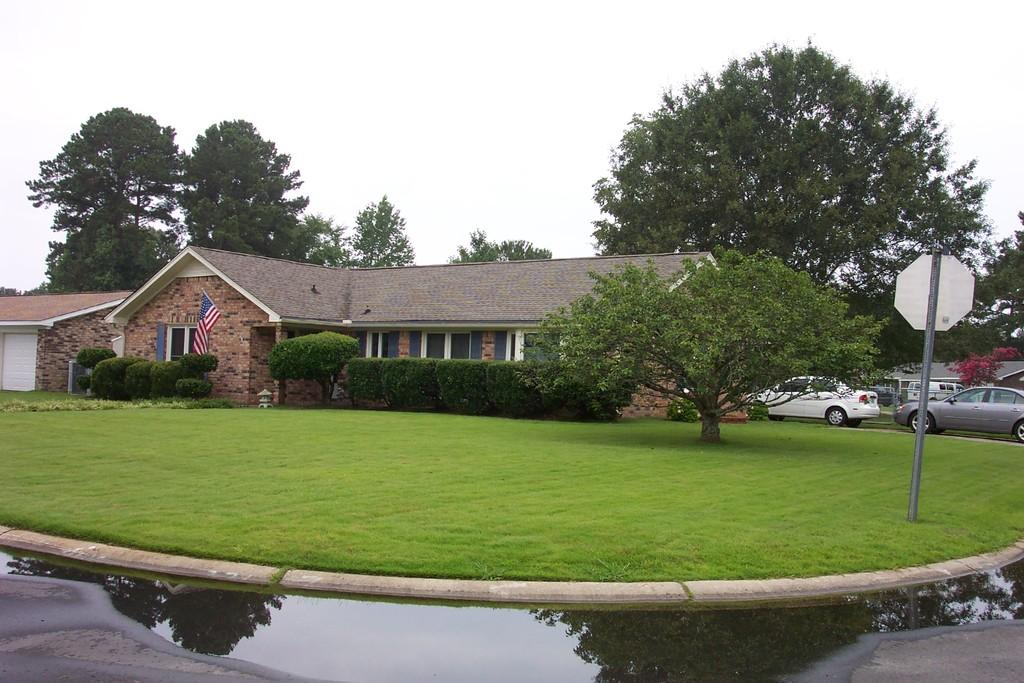What type of structures can be seen in the image? There are buildings in the image. What is flying or attached to one of the structures? There is a flag in the image. What type of vegetation is present in the image? There are bushes and trees in the image. What type of transportation can be seen on the ground in the image? Motor vehicles are visible on the ground in the image. What natural element is visible in the image? There is water visible in the image. What type of surface is present on the ground in the image? There is a pavement in the image. What part of the natural environment is visible in the image? The sky is visible in the image. Can you describe the fight between the yaks in the image? There are no yaks present in the image, so there cannot be a fight between them. How does the image change when viewed from a different angle? The image itself does not change when viewed from a different angle; it remains the same. 